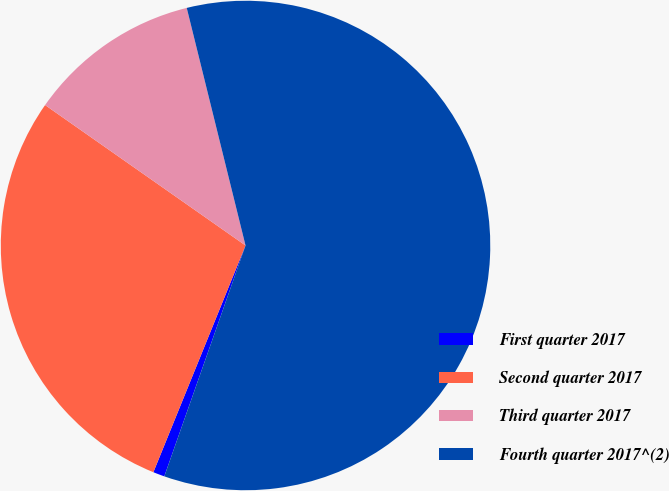Convert chart. <chart><loc_0><loc_0><loc_500><loc_500><pie_chart><fcel>First quarter 2017<fcel>Second quarter 2017<fcel>Third quarter 2017<fcel>Fourth quarter 2017^(2)<nl><fcel>0.76%<fcel>28.58%<fcel>11.41%<fcel>59.24%<nl></chart> 